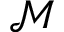<formula> <loc_0><loc_0><loc_500><loc_500>\mathcal { M }</formula> 